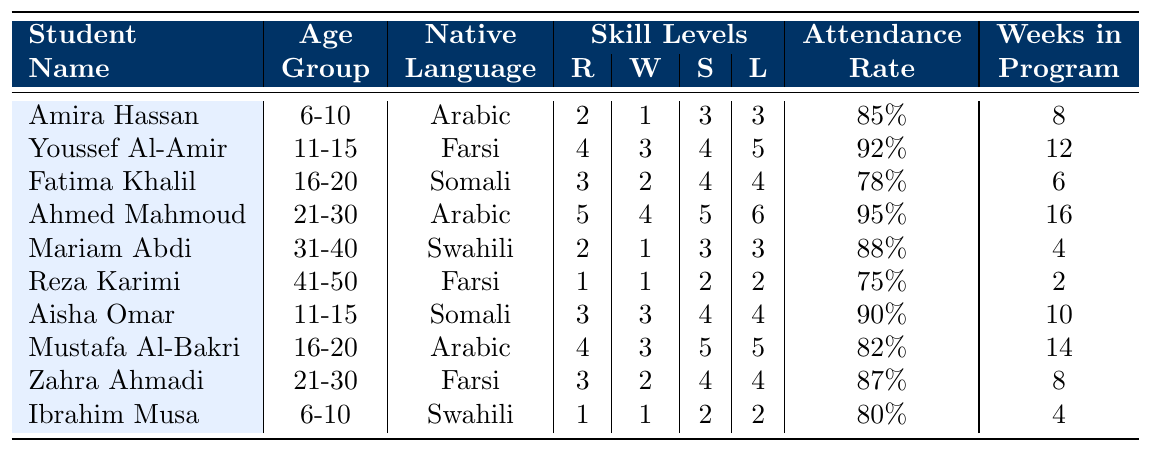What is the reading level of Amira Hassan? Amira Hassan's reading level is listed directly in the table under her name, which shows a reading level of 2.
Answer: 2 How many weeks has Ahmed Mahmoud been in the program? The table shows that Ahmed Mahmoud has been in the program for 16 weeks, as indicated in the column for "Weeks in Program."
Answer: 16 Which student has the highest writing level? The table lists writing levels, and Ahmed Mahmoud has the highest writing level of 4 among all students.
Answer: Ahmed Mahmoud What is the average attendance rate of students aged 16-20? The attendance rates for students aged 16-20 are 78%, 82%, and we can calculate the average: (78 + 82) / 2 = 80%.
Answer: 80% Is it true that Reza Karimi has the lowest listening level? By examining the listening levels, Reza Karimi's listening level is 2, which is indeed the lowest when compared to other students' listening levels.
Answer: Yes What is the total reading level of students in the 11-15 age group? The reading levels for the 11-15 age group are 4 (Youssef Al-Amir) and 3 (Aisha Omar). Adding these levels gives us 4 + 3 = 7.
Answer: 7 What is the difference in speaking levels between the youngest and oldest student in the table? The youngest student, Amira Hassan, has a speaking level of 3, and the oldest student, Reza Karimi, has a speaking level of 2. The difference is 3 - 2 = 1.
Answer: 1 Which native language group has the highest average attendance rate? To find this, we calculate the average attendance for each language group: Arabic (90%), Farsi (88.5%), Somali (81%), and Swahili (84%). Arabic has the highest average attendance at 90%.
Answer: Arabic Who has the highest attendance rate among all students? By checking the attendance rates, Ahmed Mahmoud has the highest at 95%.
Answer: Ahmed Mahmoud How many students aged 31-40 have a reading level of 2 or below? We can check and find that Mariam Abdi, who is aged 31-40, has a reading level of 2. There are no other students in that age group with reading levels of 2 or below.
Answer: 1 